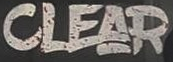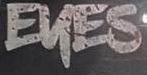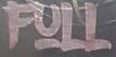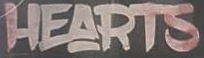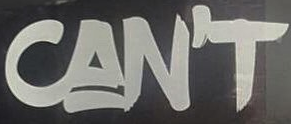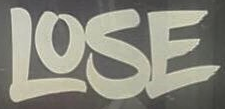Transcribe the words shown in these images in order, separated by a semicolon. CLEAR; EKES; FULL; HEARTS; CAN'T; LOSE 